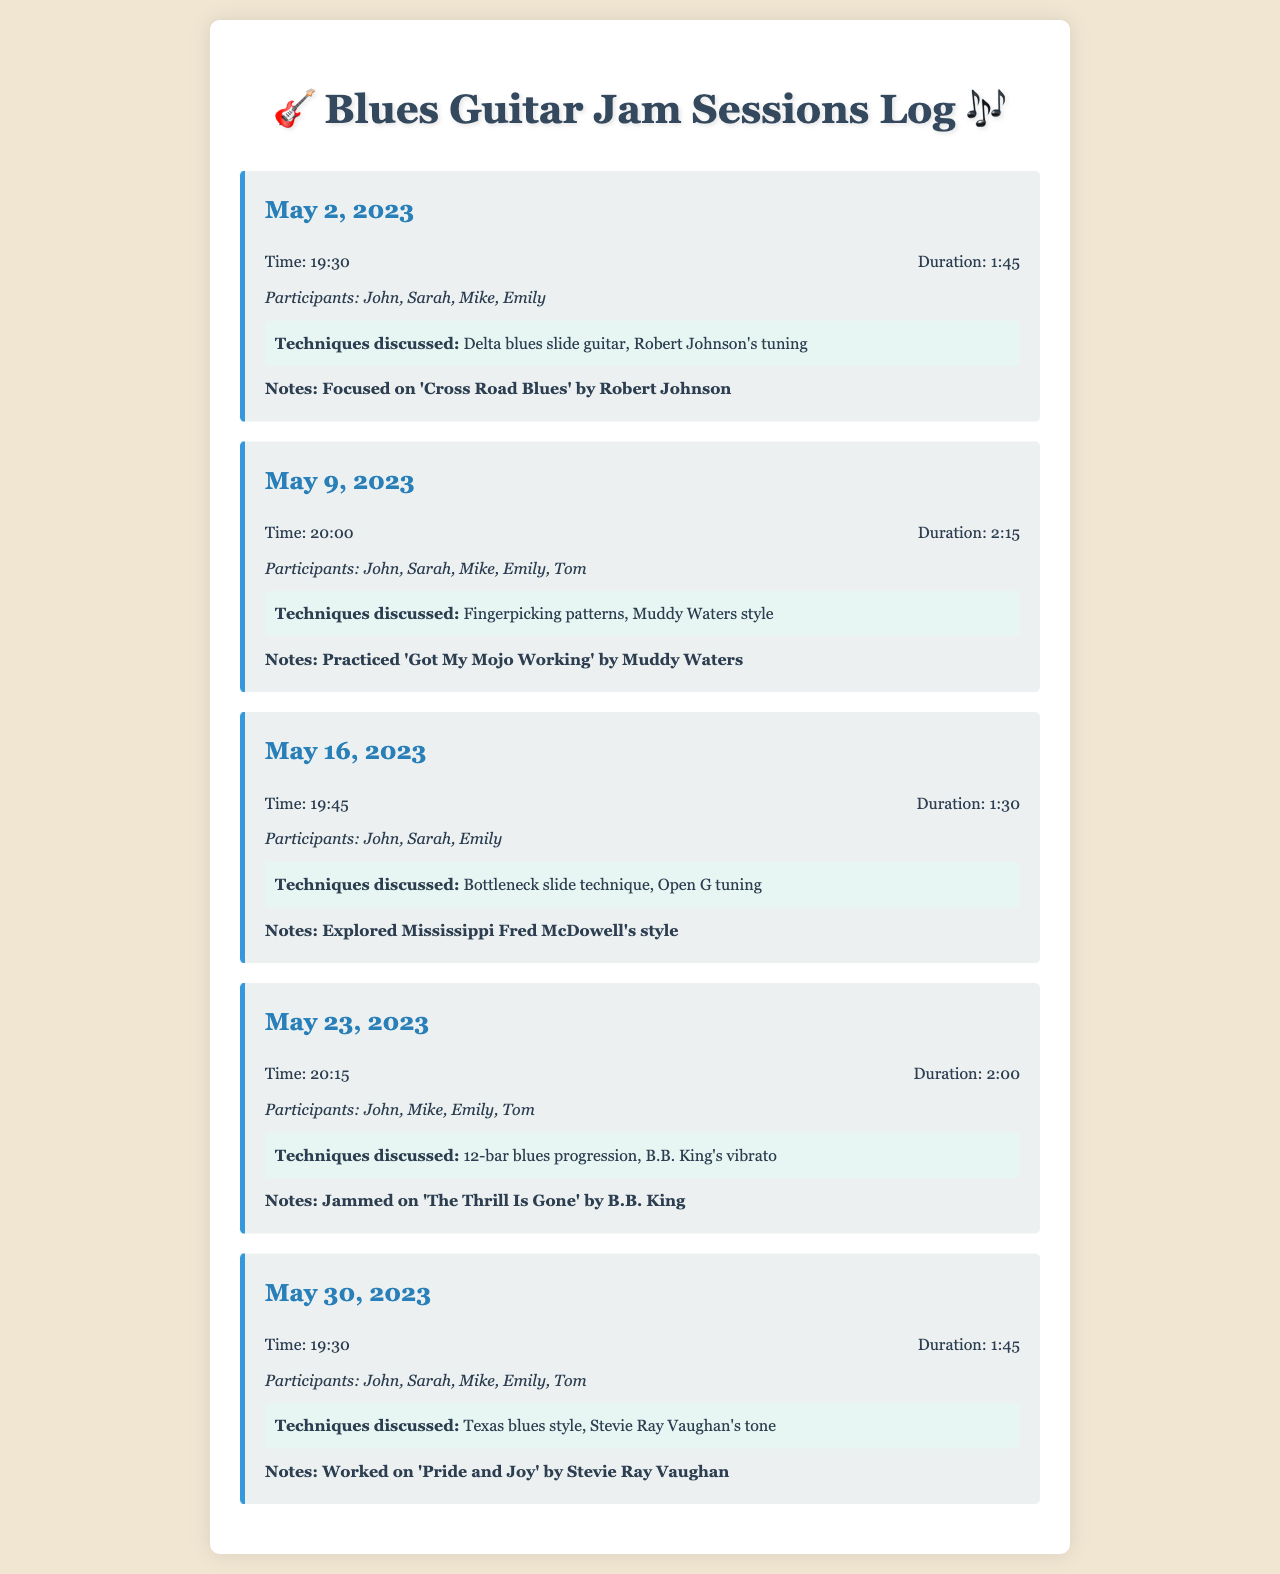What date was the session focused on 'Cross Road Blues'? The session on 'Cross Road Blues' took place on May 2, 2023, as indicated in the log.
Answer: May 2, 2023 Who participated in the session on May 9, 2023? The participants in the May 9, 2023 session were John, Sarah, Mike, Emily, and Tom, as listed in the recorded document.
Answer: John, Sarah, Mike, Emily, Tom What technique was discussed during the session on May 23, 2023? During the May 23, 2023 session, the technique discussed was the 12-bar blues progression, as noted in the log.
Answer: 12-bar blues progression How long did the practice session on May 16, 2023 last? The duration of the May 16, 2023 session was 1 hour and 30 minutes, which is provided in the session details.
Answer: 1:30 Which song was practiced in the session on May 30, 2023? The song practiced during the May 30, 2023 session was 'Pride and Joy' by Stevie Ray Vaughan, as mentioned in the notes.
Answer: Pride and Joy How many techniques were discussed in the session on May 16, 2023? The techniques discussed in the May 16, 2023 session were two: Bottleneck slide technique and Open G tuning, as described in the document.
Answer: Two What was the time of the session on May 2, 2023? The session on May 2, 2023 started at 19:30, which is specified in the session details.
Answer: 19:30 Which artist's tuning was discussed in the session on May 2, 2023? The tuning discussed in the May 2, 2023 session was Robert Johnson's tuning, as mentioned in the documentation.
Answer: Robert Johnson's tuning 